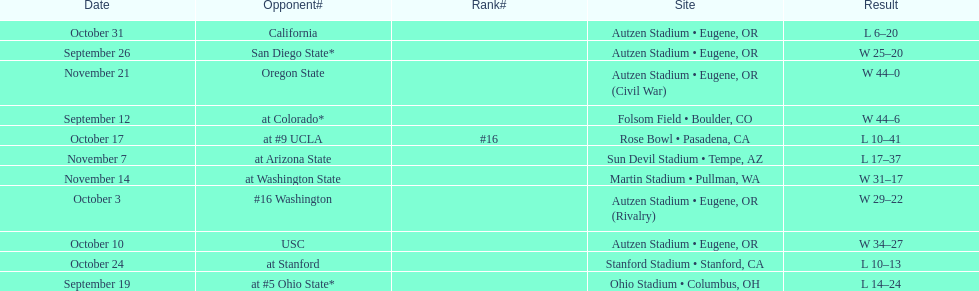How many games did the team win while not at home? 2. 